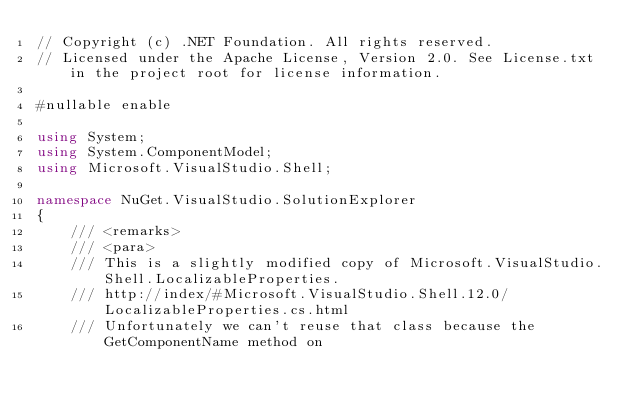<code> <loc_0><loc_0><loc_500><loc_500><_C#_>// Copyright (c) .NET Foundation. All rights reserved.
// Licensed under the Apache License, Version 2.0. See License.txt in the project root for license information.

#nullable enable

using System;
using System.ComponentModel;
using Microsoft.VisualStudio.Shell;

namespace NuGet.VisualStudio.SolutionExplorer
{
    /// <remarks>
    /// <para>
    /// This is a slightly modified copy of Microsoft.VisualStudio.Shell.LocalizableProperties.
    /// http://index/#Microsoft.VisualStudio.Shell.12.0/LocalizableProperties.cs.html
    /// Unfortunately we can't reuse that class because the GetComponentName method on</code> 